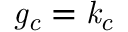<formula> <loc_0><loc_0><loc_500><loc_500>g _ { c } = k _ { c }</formula> 